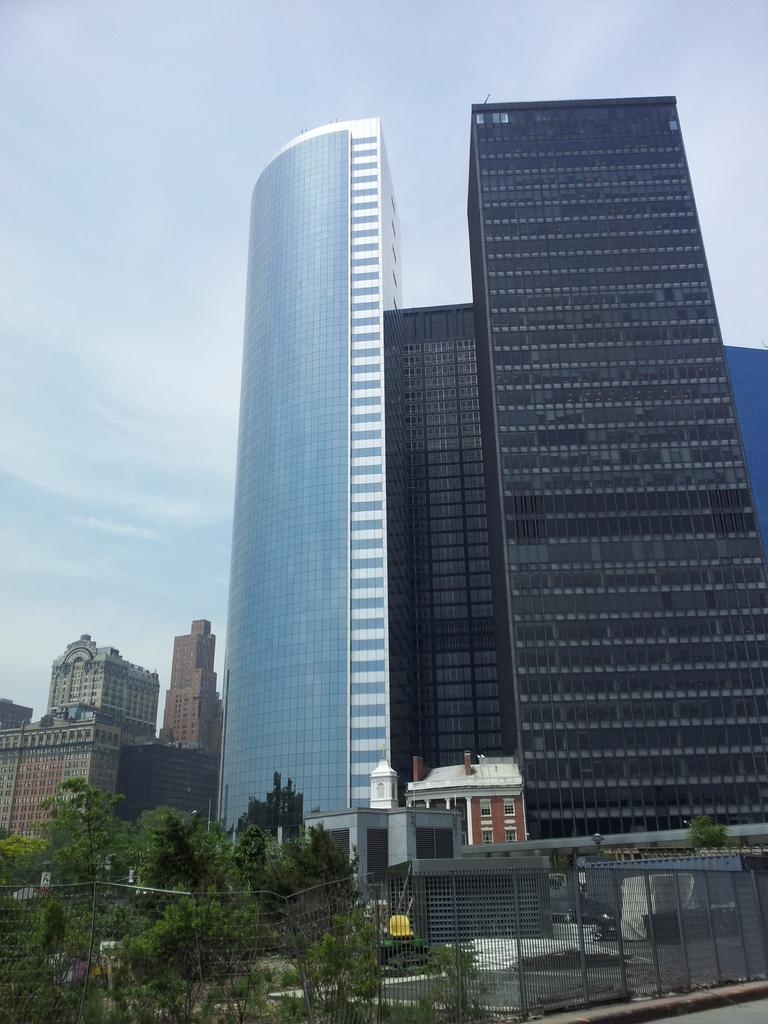What type of structures are present in the image? There are buildings in the image. What other natural elements can be seen in the image? There are trees in the image. What is visible at the top of the image? The sky is visible at the top of the image. Can you tell me where the monkey is sitting in the image? There is no monkey present in the image. What idea does the image represent? The image does not represent any specific idea; it simply shows buildings, trees, and the sky. 